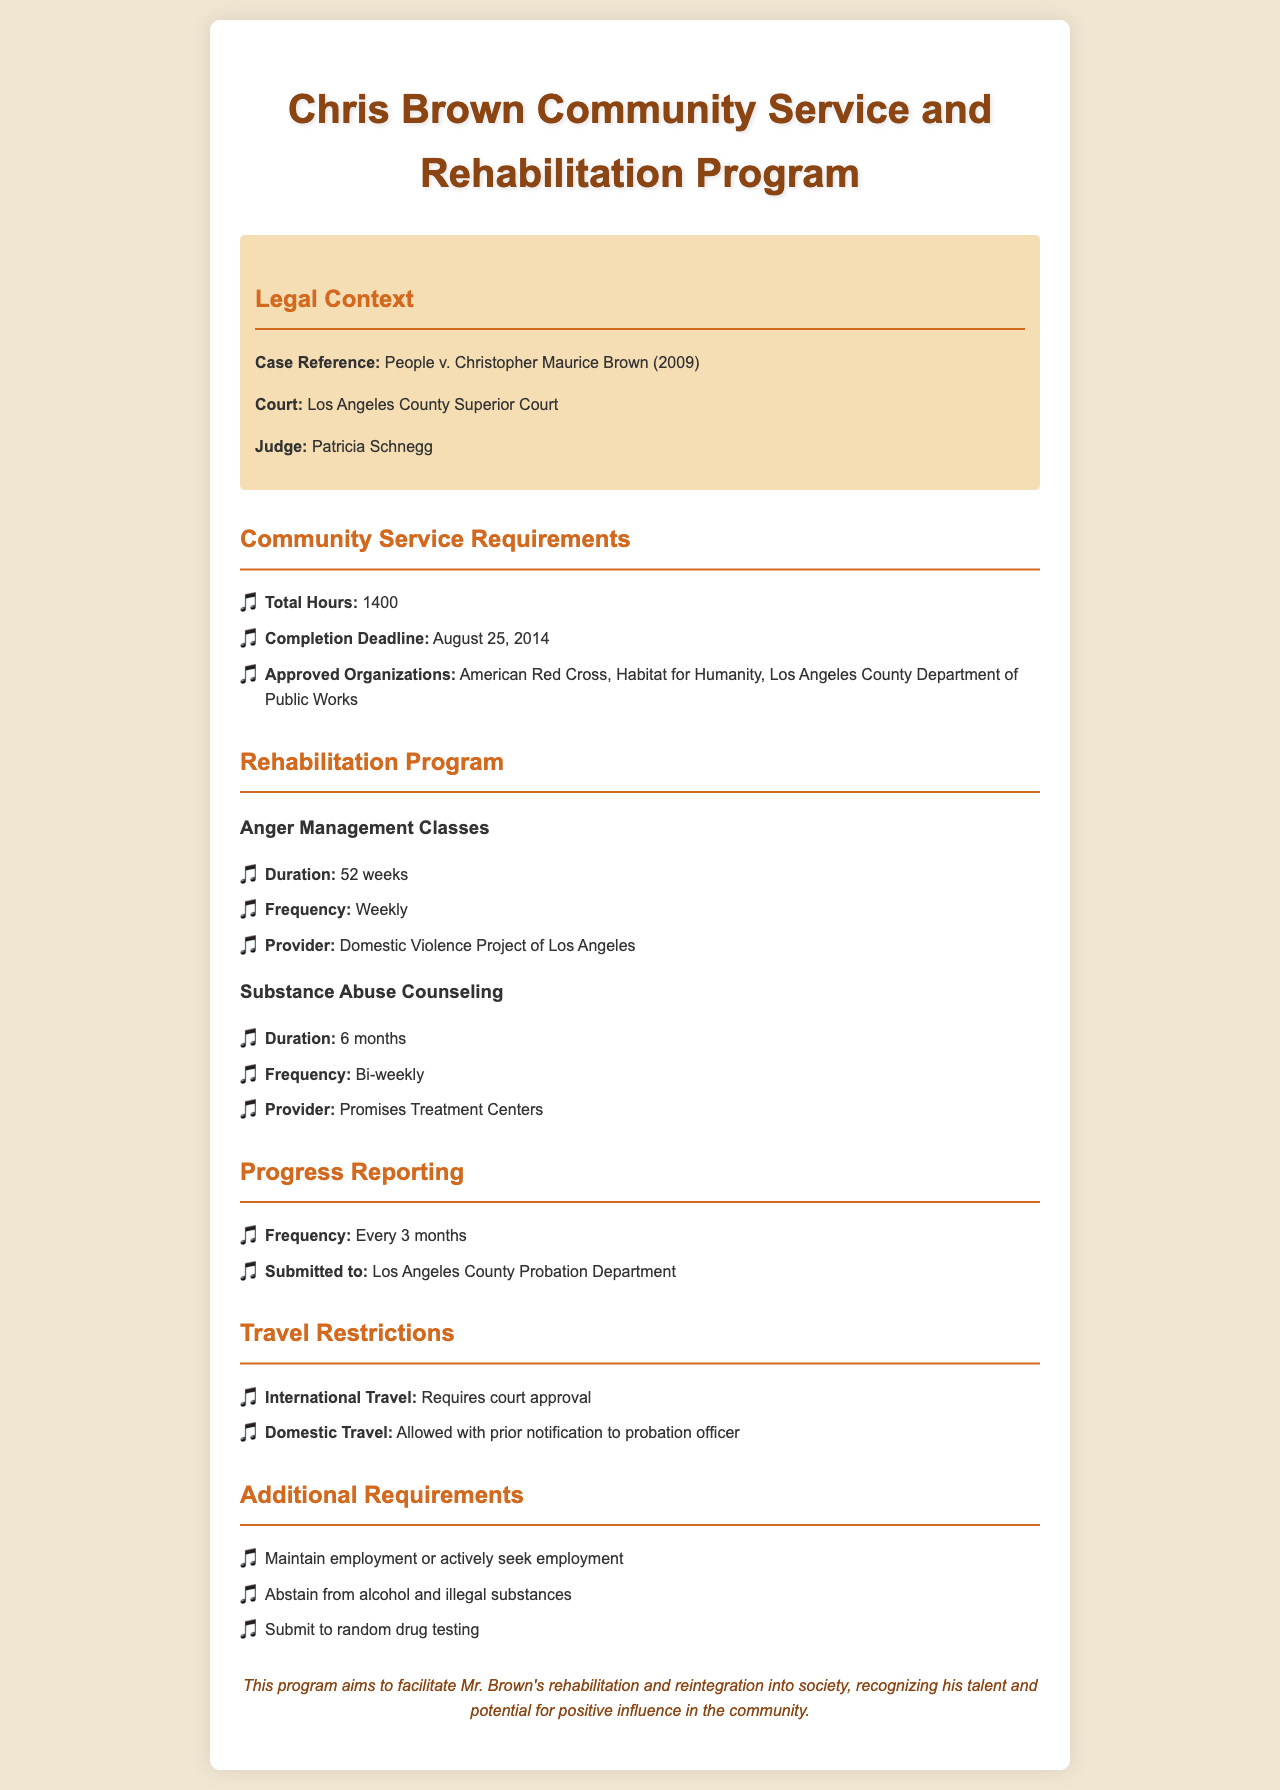what is the total number of community service hours required? The document states that Chris Brown is required to complete a total of 1400 community service hours.
Answer: 1400 when is the completion deadline for the community service? The completion deadline for the community service is noted in the document as August 25, 2014.
Answer: August 25, 2014 how long is the anger management class duration? The document indicates that the duration of the anger management classes is 52 weeks.
Answer: 52 weeks who provides the substance abuse counseling? The document specifies that the substance abuse counseling is provided by Promises Treatment Centers.
Answer: Promises Treatment Centers how often are progress reports submitted? The document mentions that progress reports are submitted every 3 months to the Los Angeles County Probation Department.
Answer: Every 3 months are international travel restrictions mentioned in the document? The document states that international travel requires court approval, indicating travel restrictions.
Answer: Requires court approval what is a condition of the additional requirements listed? One of the additional requirements includes maintaining employment or actively seeking employment.
Answer: Maintain employment or actively seek employment which organization is approved for community service? The document lists the American Red Cross as one of the approved organizations for community service.
Answer: American Red Cross what is the frequency of the substance abuse counseling sessions? According to the document, substance abuse counseling sessions are scheduled bi-weekly.
Answer: Bi-weekly 